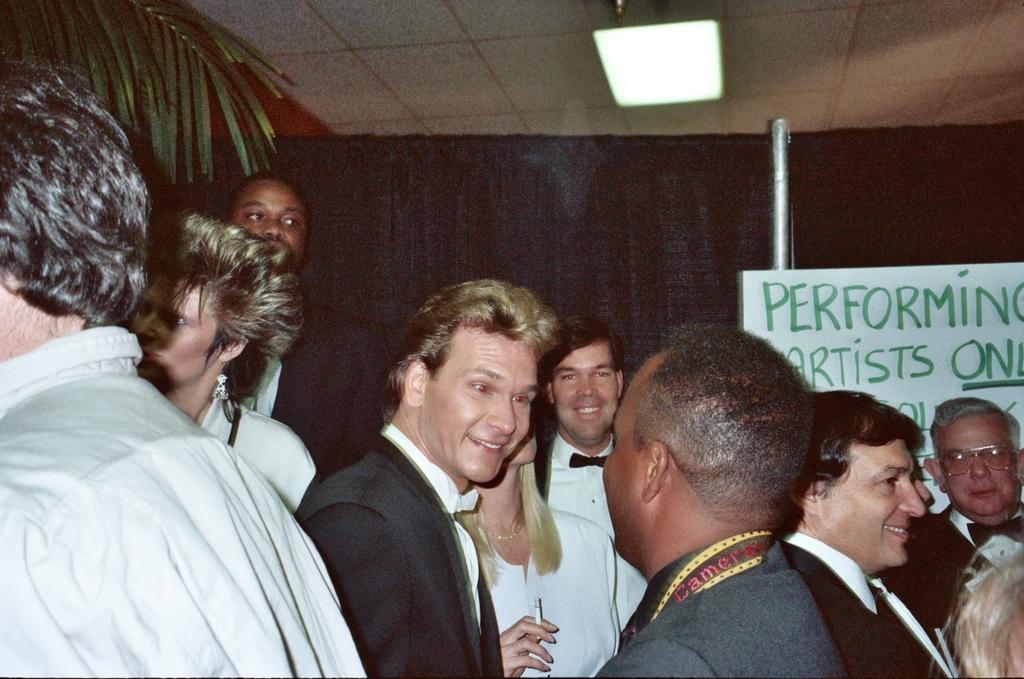Could you give a brief overview of what you see in this image? In this image I see number of people in which these 3 men are smiling and I see a board over here on which there is something written and it is black over here and I see this light on the ceiling and I see the green leaves over here. 